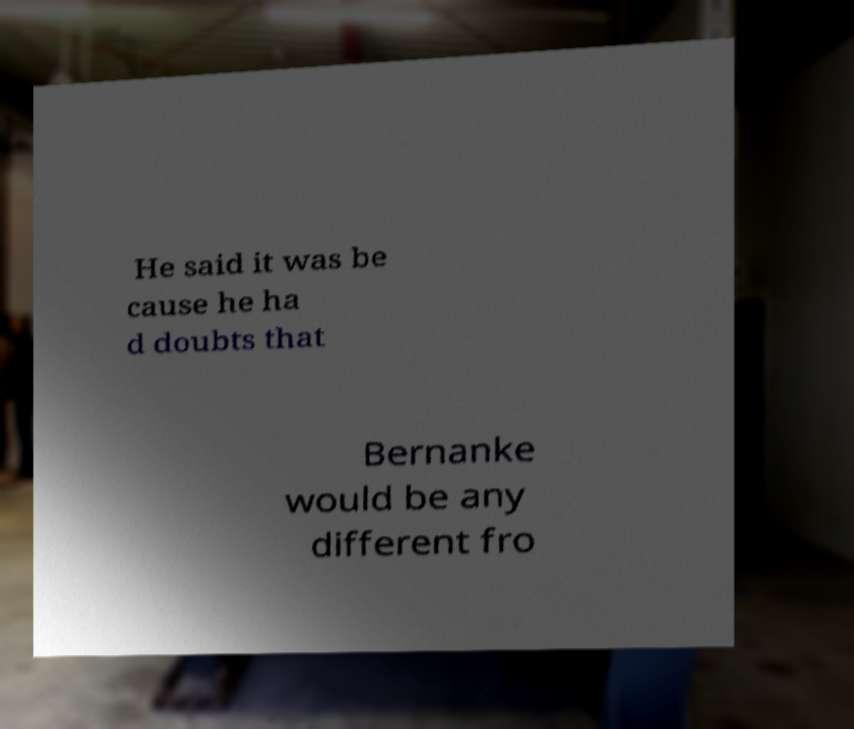I need the written content from this picture converted into text. Can you do that? He said it was be cause he ha d doubts that Bernanke would be any different fro 